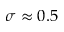<formula> <loc_0><loc_0><loc_500><loc_500>\sigma \approx 0 . 5</formula> 